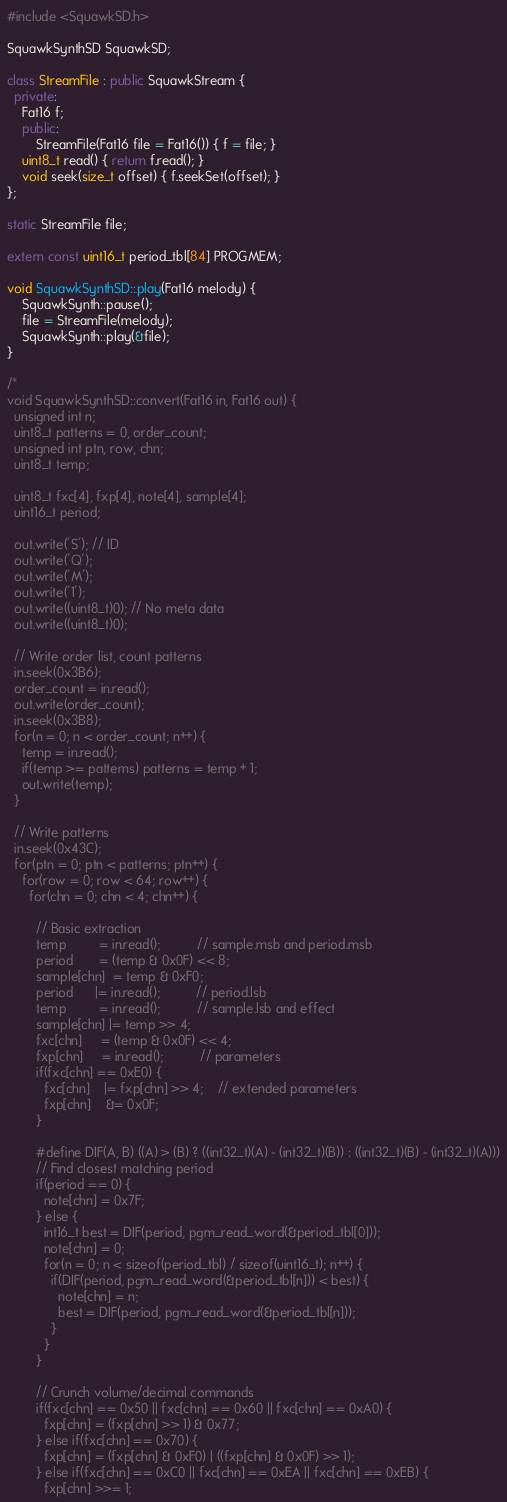Convert code to text. <code><loc_0><loc_0><loc_500><loc_500><_C++_>#include <SquawkSD.h>

SquawkSynthSD SquawkSD;

class StreamFile : public SquawkStream {
  private:
    Fat16 f;
	public:
		StreamFile(Fat16 file = Fat16()) { f = file; }
    uint8_t read() { return f.read(); }
    void seek(size_t offset) { f.seekSet(offset); }
};

static StreamFile file;

extern const uint16_t period_tbl[84] PROGMEM;

void SquawkSynthSD::play(Fat16 melody) {
	SquawkSynth::pause();
	file = StreamFile(melody);
	SquawkSynth::play(&file);
}

/*
void SquawkSynthSD::convert(Fat16 in, Fat16 out) {
  unsigned int n;
  uint8_t patterns = 0, order_count;
  unsigned int ptn, row, chn;
  uint8_t temp;

  uint8_t fxc[4], fxp[4], note[4], sample[4];
  uint16_t period;

  out.write('S'); // ID
  out.write('Q');
  out.write('M');
  out.write('1');
  out.write((uint8_t)0); // No meta data
  out.write((uint8_t)0);
  
  // Write order list, count patterns
  in.seek(0x3B6);
  order_count = in.read();
  out.write(order_count);
  in.seek(0x3B8);
  for(n = 0; n < order_count; n++) {
    temp = in.read();
    if(temp >= patterns) patterns = temp + 1;
    out.write(temp);
  }
  
  // Write patterns
  in.seek(0x43C);
  for(ptn = 0; ptn < patterns; ptn++) {
    for(row = 0; row < 64; row++) {
      for(chn = 0; chn < 4; chn++) {
        
        // Basic extraction
        temp         = in.read();          // sample.msb and period.msb
        period       = (temp & 0x0F) << 8;
        sample[chn]  = temp & 0xF0;
        period      |= in.read();          // period.lsb
        temp         = in.read();          // sample.lsb and effect
        sample[chn] |= temp >> 4;
        fxc[chn]     = (temp & 0x0F) << 4;
        fxp[chn]     = in.read();          // parameters
        if(fxc[chn] == 0xE0) {
          fxc[chn]    |= fxp[chn] >> 4;    // extended parameters
          fxp[chn]    &= 0x0F;
        }
        
        #define DIF(A, B) ((A) > (B) ? ((int32_t)(A) - (int32_t)(B)) : ((int32_t)(B) - (int32_t)(A)))
        // Find closest matching period
        if(period == 0) {
          note[chn] = 0x7F;
        } else {
          int16_t best = DIF(period, pgm_read_word(&period_tbl[0]));
          note[chn] = 0;
          for(n = 0; n < sizeof(period_tbl) / sizeof(uint16_t); n++) {
            if(DIF(period, pgm_read_word(&period_tbl[n])) < best) {
              note[chn] = n;
              best = DIF(period, pgm_read_word(&period_tbl[n]));
            }
          }
        }
        
        // Crunch volume/decimal commands
        if(fxc[chn] == 0x50 || fxc[chn] == 0x60 || fxc[chn] == 0xA0) {
          fxp[chn] = (fxp[chn] >> 1) & 0x77;
        } else if(fxc[chn] == 0x70) {
          fxp[chn] = (fxp[chn] & 0xF0) | ((fxp[chn] & 0x0F) >> 1);
        } else if(fxc[chn] == 0xC0 || fxc[chn] == 0xEA || fxc[chn] == 0xEB) {
          fxp[chn] >>= 1;</code> 